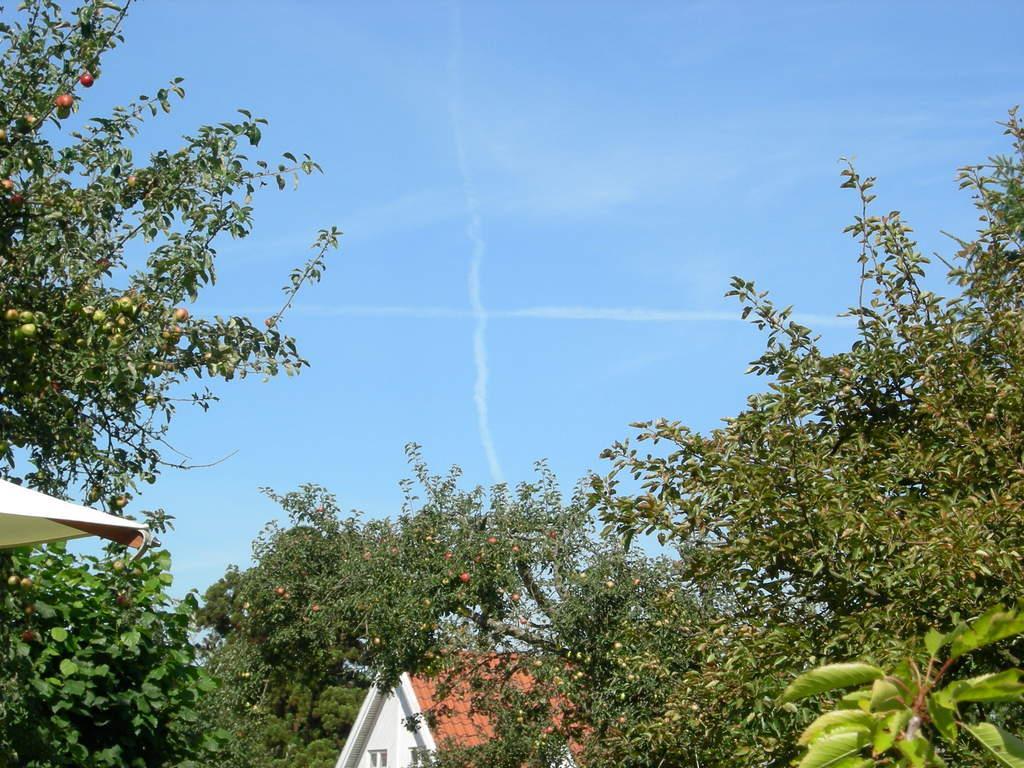Please provide a concise description of this image. In this picture we can see trees. At the bottom of the image, there is a house. At the top of the image, there is the sky. On the left side of the image, there is an object. 